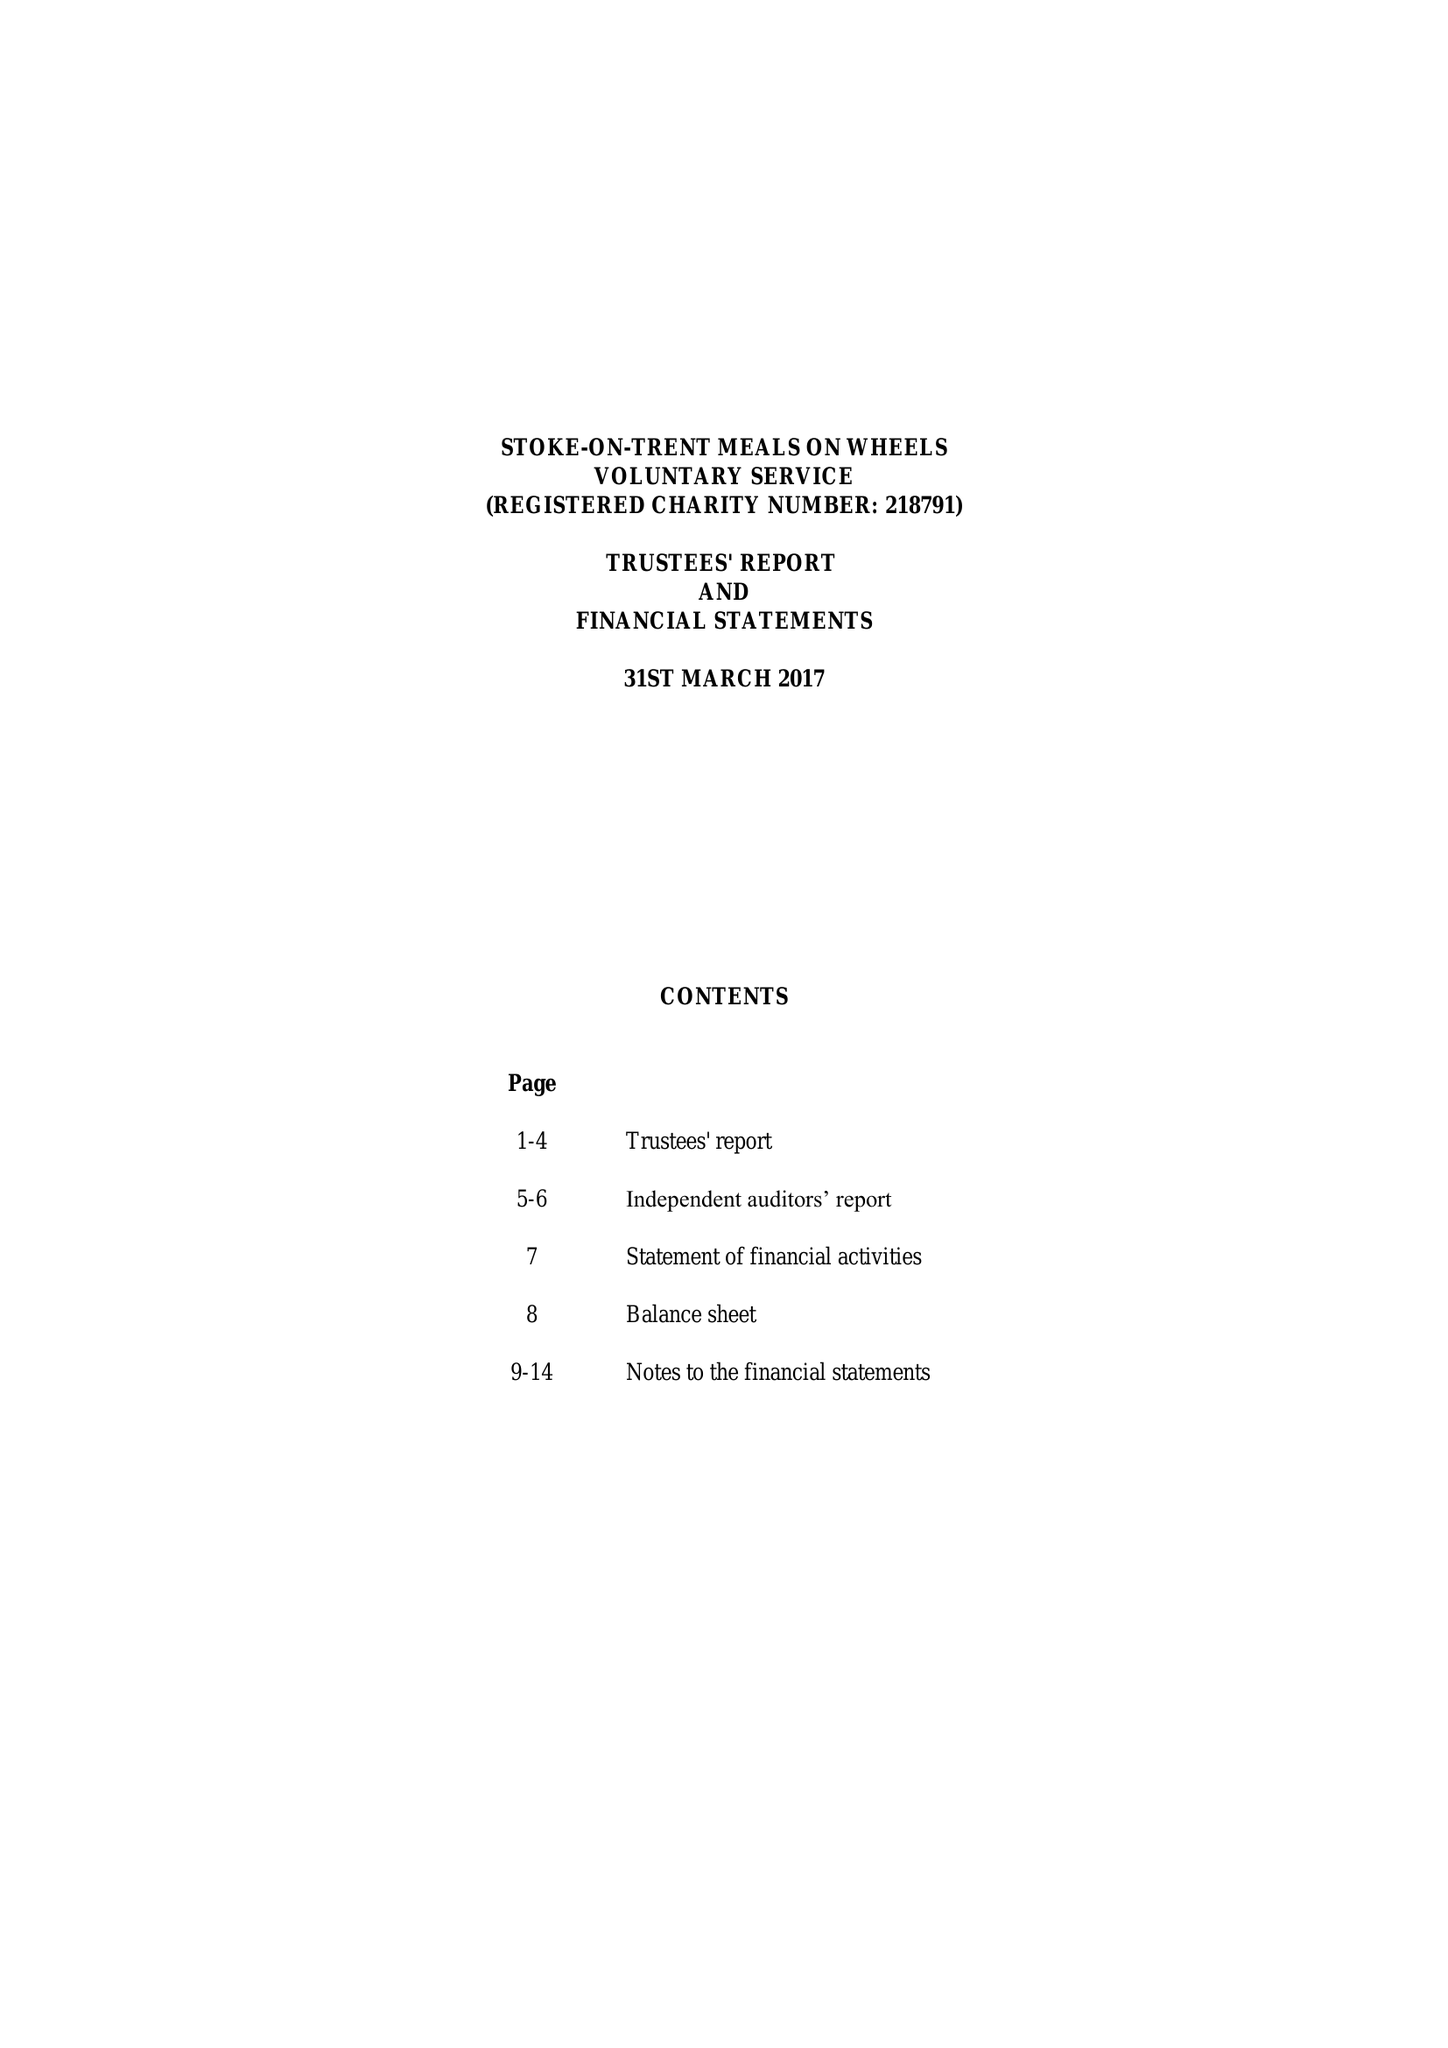What is the value for the address__street_line?
Answer the question using a single word or phrase. 5 PARK ROAD 